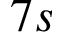<formula> <loc_0><loc_0><loc_500><loc_500>7 s</formula> 